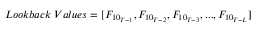Convert formula to latex. <formula><loc_0><loc_0><loc_500><loc_500>L o o k b a c k \, V a l u e s = [ F _ { { 1 0 } _ { T - 1 } } , F _ { { 1 0 } _ { T - 2 } } , F _ { { 1 0 } _ { T - 3 } } , \dots , F _ { { 1 0 } _ { T - L } } ]</formula> 